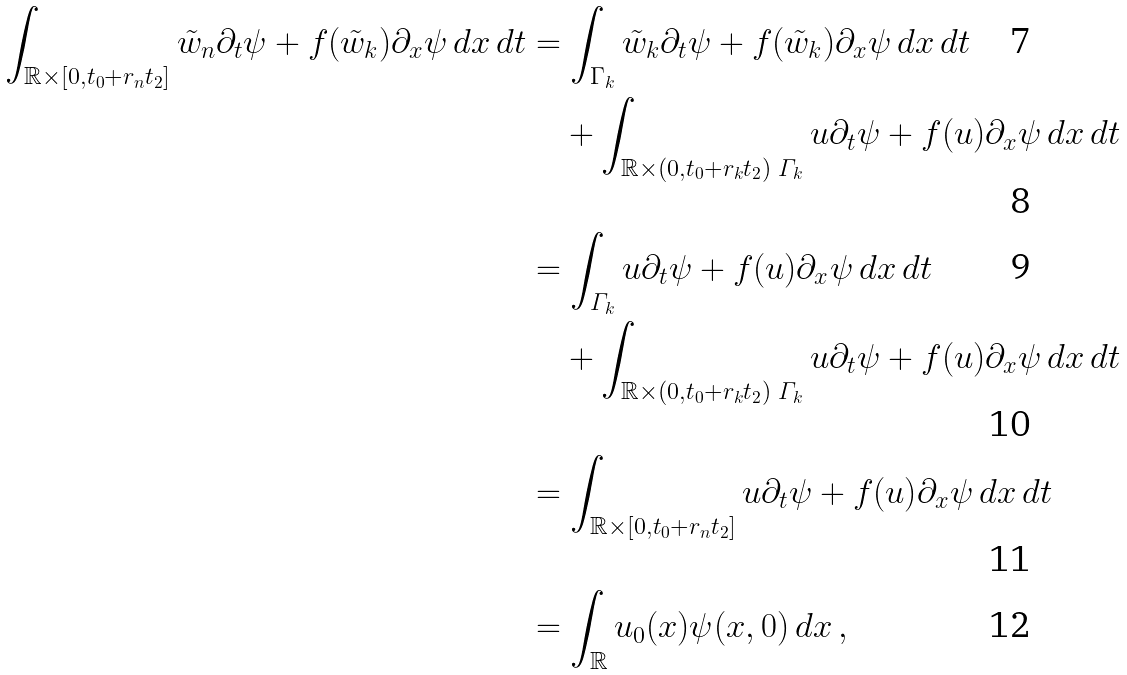<formula> <loc_0><loc_0><loc_500><loc_500>\int _ { \mathbb { R } \times [ 0 , t _ { 0 } + r _ { n } t _ { 2 } ] } \tilde { w } _ { n } \partial _ { t } \psi + f ( \tilde { w } _ { k } ) \partial _ { x } \psi \, d x \, d t & = \int _ { \Gamma _ { k } } \tilde { w } _ { k } \partial _ { t } \psi + f ( \tilde { w } _ { k } ) \partial _ { x } \psi \, d x \, d t \\ & \quad + \int _ { \mathbb { R } \times ( 0 , t _ { 0 } + r _ { k } t _ { 2 } ) \ \varGamma _ { k } } u \partial _ { t } \psi + f ( u ) \partial _ { x } \psi \, d x \, d t \\ & = \int _ { \varGamma _ { k } } u \partial _ { t } \psi + f ( u ) \partial _ { x } \psi \, d x \, d t \\ & \quad + \int _ { \mathbb { R } \times ( 0 , t _ { 0 } + r _ { k } t _ { 2 } ) \ \varGamma _ { k } } u \partial _ { t } \psi + f ( u ) \partial _ { x } \psi \, d x \, d t \\ & = \int _ { \mathbb { R } \times [ 0 , t _ { 0 } + r _ { n } t _ { 2 } ] } u \partial _ { t } \psi + f ( u ) \partial _ { x } \psi \, d x \, d t \\ & = \int _ { \mathbb { R } } u _ { 0 } ( x ) \psi ( x , 0 ) \, d x \, ,</formula> 